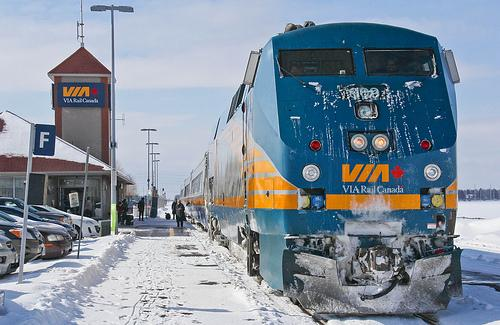What kind of activity can be inferred in the image and why? A train has stopped at a train station during winter as people walk and stand near the train, cars are parked nearby, and snow covers various objects in the scene. Discuss the weather condition and the implications it has on the image. The weather condition in the image is snowy, which leads to snow accumulation on the train, train station, and walkways, creating a cold and wintery atmosphere. What is the dominant feature of the image and how does it appear? The dominant feature of the image is a blue train with yellow lines in snow, and it has multiple windows, headlights, and a red maple leaf on it. Notice the purple sign with white text on it. There is a blue sign with white letter, but no purple sign exists in the image. Find the presence of trees without snow on them. There are tree above the snowy horizon, but all trees in the image have snow on them. Look for a train station with a green roof. There is a train station in the image, but it has a red roof covered with snow, not a green one. Do you see any cars with open doors in the parking lot? There are cars parked at the train station, but none of them have open doors. Observe a person riding a bicycle near the train. There are people walking and standing near the train, but there is no person riding a bicycle. Can you find the green train in the image? There is a blue train in snow, but no green train exists in the image. Can you find a person wearing a red hat near the train? There are people near the train, but none of them are wearing a red hat. There's an airplane in the sky above the train. There is no airplane present in the image, only items related to the train and the station. Locate a dog playing in the snow near the train station. There are people and objects like cars and lampposts, but there is no dog playing in the snow. Identify a group of children playing in the snow. There are people standing and walking near the train, but no group of children playing in the snow is present in the image. 